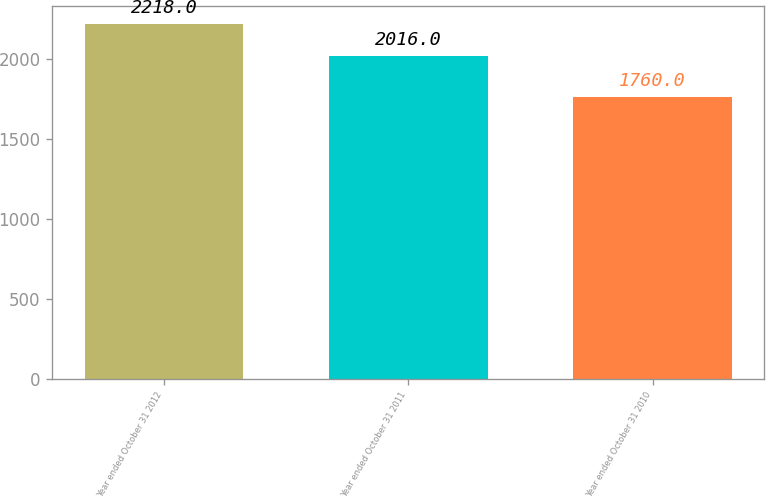<chart> <loc_0><loc_0><loc_500><loc_500><bar_chart><fcel>Year ended October 31 2012<fcel>Year ended October 31 2011<fcel>Year ended October 31 2010<nl><fcel>2218<fcel>2016<fcel>1760<nl></chart> 